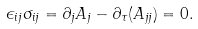Convert formula to latex. <formula><loc_0><loc_0><loc_500><loc_500>\epsilon _ { i j } \sigma _ { i j } = \partial _ { j } A _ { j } - \partial _ { \tau } ( A _ { j j } ) = 0 .</formula> 